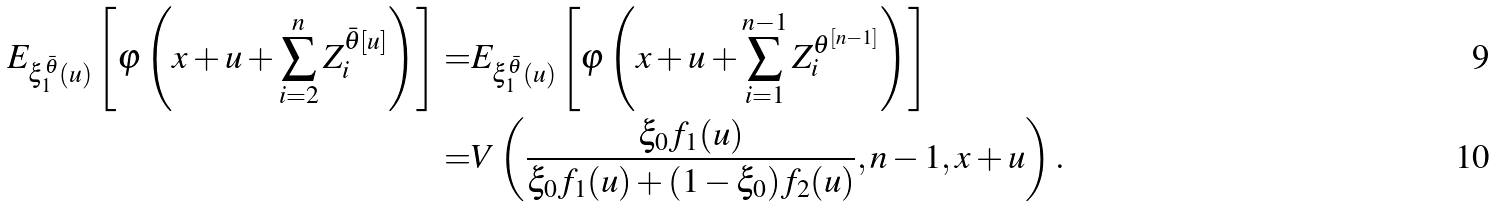<formula> <loc_0><loc_0><loc_500><loc_500>E _ { \xi ^ { \bar { \theta } } _ { 1 } ( u ) } \left [ \varphi \left ( x + u + \sum _ { i = 2 } ^ { n } Z ^ { { \bar { \theta } } [ u ] } _ { i } \right ) \right ] = & E _ { \xi ^ { \bar { \theta } } _ { 1 } ( u ) } \left [ \varphi \left ( x + u + \sum _ { i = 1 } ^ { n - 1 } Z ^ { \theta ^ { [ n - 1 ] } } _ { i } \right ) \right ] \\ = & V \left ( \frac { \xi _ { 0 } f _ { 1 } ( u ) } { \xi _ { 0 } f _ { 1 } ( u ) + ( 1 - \xi _ { 0 } ) f _ { 2 } ( u ) } , n - 1 , x + u \right ) .</formula> 